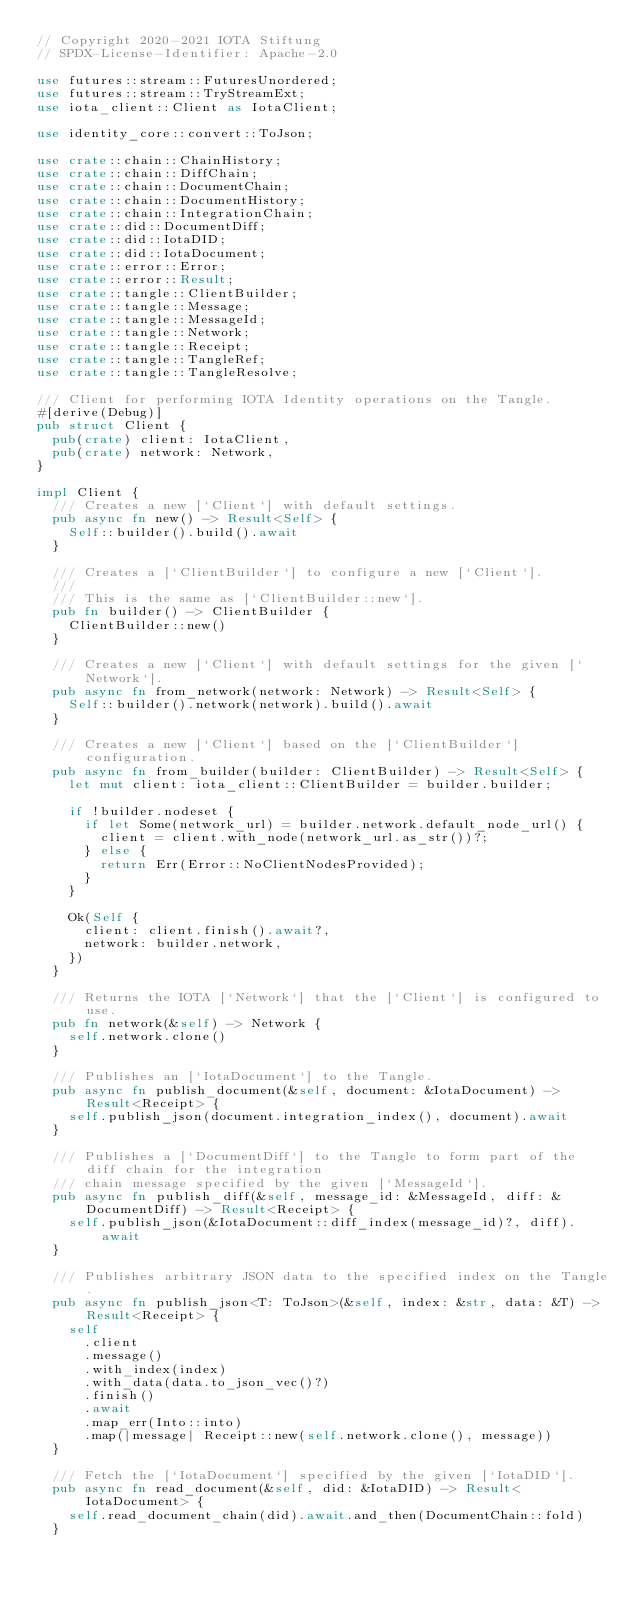<code> <loc_0><loc_0><loc_500><loc_500><_Rust_>// Copyright 2020-2021 IOTA Stiftung
// SPDX-License-Identifier: Apache-2.0

use futures::stream::FuturesUnordered;
use futures::stream::TryStreamExt;
use iota_client::Client as IotaClient;

use identity_core::convert::ToJson;

use crate::chain::ChainHistory;
use crate::chain::DiffChain;
use crate::chain::DocumentChain;
use crate::chain::DocumentHistory;
use crate::chain::IntegrationChain;
use crate::did::DocumentDiff;
use crate::did::IotaDID;
use crate::did::IotaDocument;
use crate::error::Error;
use crate::error::Result;
use crate::tangle::ClientBuilder;
use crate::tangle::Message;
use crate::tangle::MessageId;
use crate::tangle::Network;
use crate::tangle::Receipt;
use crate::tangle::TangleRef;
use crate::tangle::TangleResolve;

/// Client for performing IOTA Identity operations on the Tangle.
#[derive(Debug)]
pub struct Client {
  pub(crate) client: IotaClient,
  pub(crate) network: Network,
}

impl Client {
  /// Creates a new [`Client`] with default settings.
  pub async fn new() -> Result<Self> {
    Self::builder().build().await
  }

  /// Creates a [`ClientBuilder`] to configure a new [`Client`].
  ///
  /// This is the same as [`ClientBuilder::new`].
  pub fn builder() -> ClientBuilder {
    ClientBuilder::new()
  }

  /// Creates a new [`Client`] with default settings for the given [`Network`].
  pub async fn from_network(network: Network) -> Result<Self> {
    Self::builder().network(network).build().await
  }

  /// Creates a new [`Client`] based on the [`ClientBuilder`] configuration.
  pub async fn from_builder(builder: ClientBuilder) -> Result<Self> {
    let mut client: iota_client::ClientBuilder = builder.builder;

    if !builder.nodeset {
      if let Some(network_url) = builder.network.default_node_url() {
        client = client.with_node(network_url.as_str())?;
      } else {
        return Err(Error::NoClientNodesProvided);
      }
    }

    Ok(Self {
      client: client.finish().await?,
      network: builder.network,
    })
  }

  /// Returns the IOTA [`Network`] that the [`Client`] is configured to use.
  pub fn network(&self) -> Network {
    self.network.clone()
  }

  /// Publishes an [`IotaDocument`] to the Tangle.
  pub async fn publish_document(&self, document: &IotaDocument) -> Result<Receipt> {
    self.publish_json(document.integration_index(), document).await
  }

  /// Publishes a [`DocumentDiff`] to the Tangle to form part of the diff chain for the integration
  /// chain message specified by the given [`MessageId`].
  pub async fn publish_diff(&self, message_id: &MessageId, diff: &DocumentDiff) -> Result<Receipt> {
    self.publish_json(&IotaDocument::diff_index(message_id)?, diff).await
  }

  /// Publishes arbitrary JSON data to the specified index on the Tangle.
  pub async fn publish_json<T: ToJson>(&self, index: &str, data: &T) -> Result<Receipt> {
    self
      .client
      .message()
      .with_index(index)
      .with_data(data.to_json_vec()?)
      .finish()
      .await
      .map_err(Into::into)
      .map(|message| Receipt::new(self.network.clone(), message))
  }

  /// Fetch the [`IotaDocument`] specified by the given [`IotaDID`].
  pub async fn read_document(&self, did: &IotaDID) -> Result<IotaDocument> {
    self.read_document_chain(did).await.and_then(DocumentChain::fold)
  }
</code> 